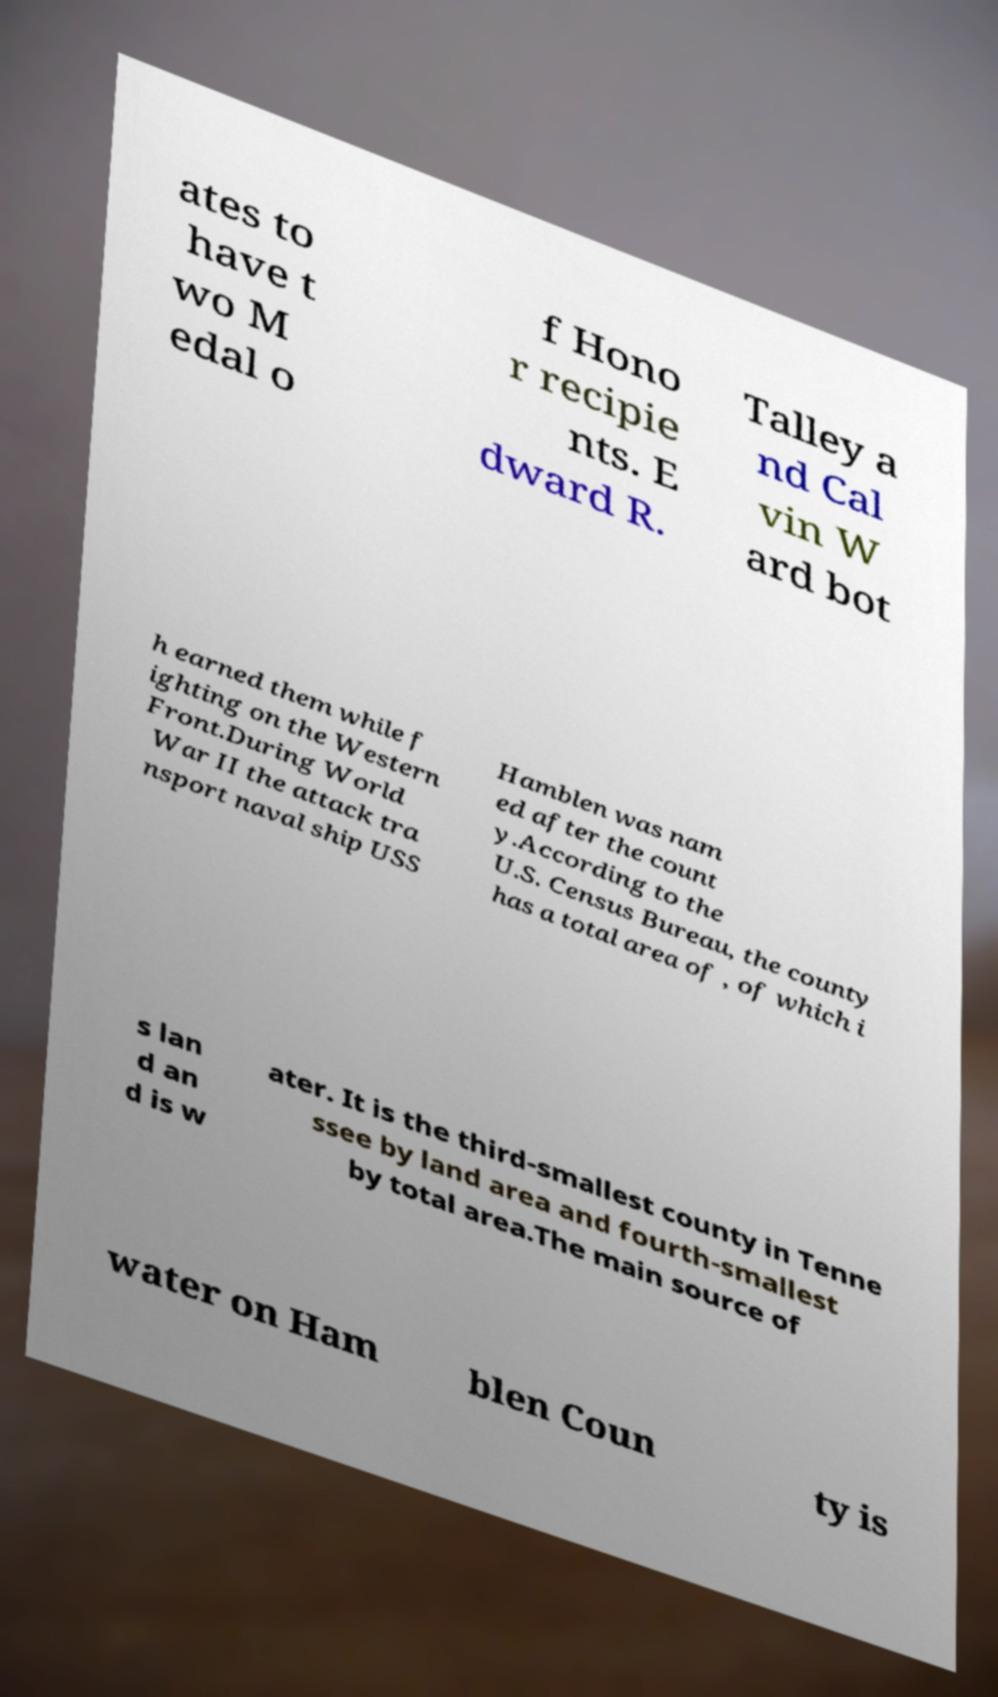For documentation purposes, I need the text within this image transcribed. Could you provide that? ates to have t wo M edal o f Hono r recipie nts. E dward R. Talley a nd Cal vin W ard bot h earned them while f ighting on the Western Front.During World War II the attack tra nsport naval ship USS Hamblen was nam ed after the count y.According to the U.S. Census Bureau, the county has a total area of , of which i s lan d an d is w ater. It is the third-smallest county in Tenne ssee by land area and fourth-smallest by total area.The main source of water on Ham blen Coun ty is 